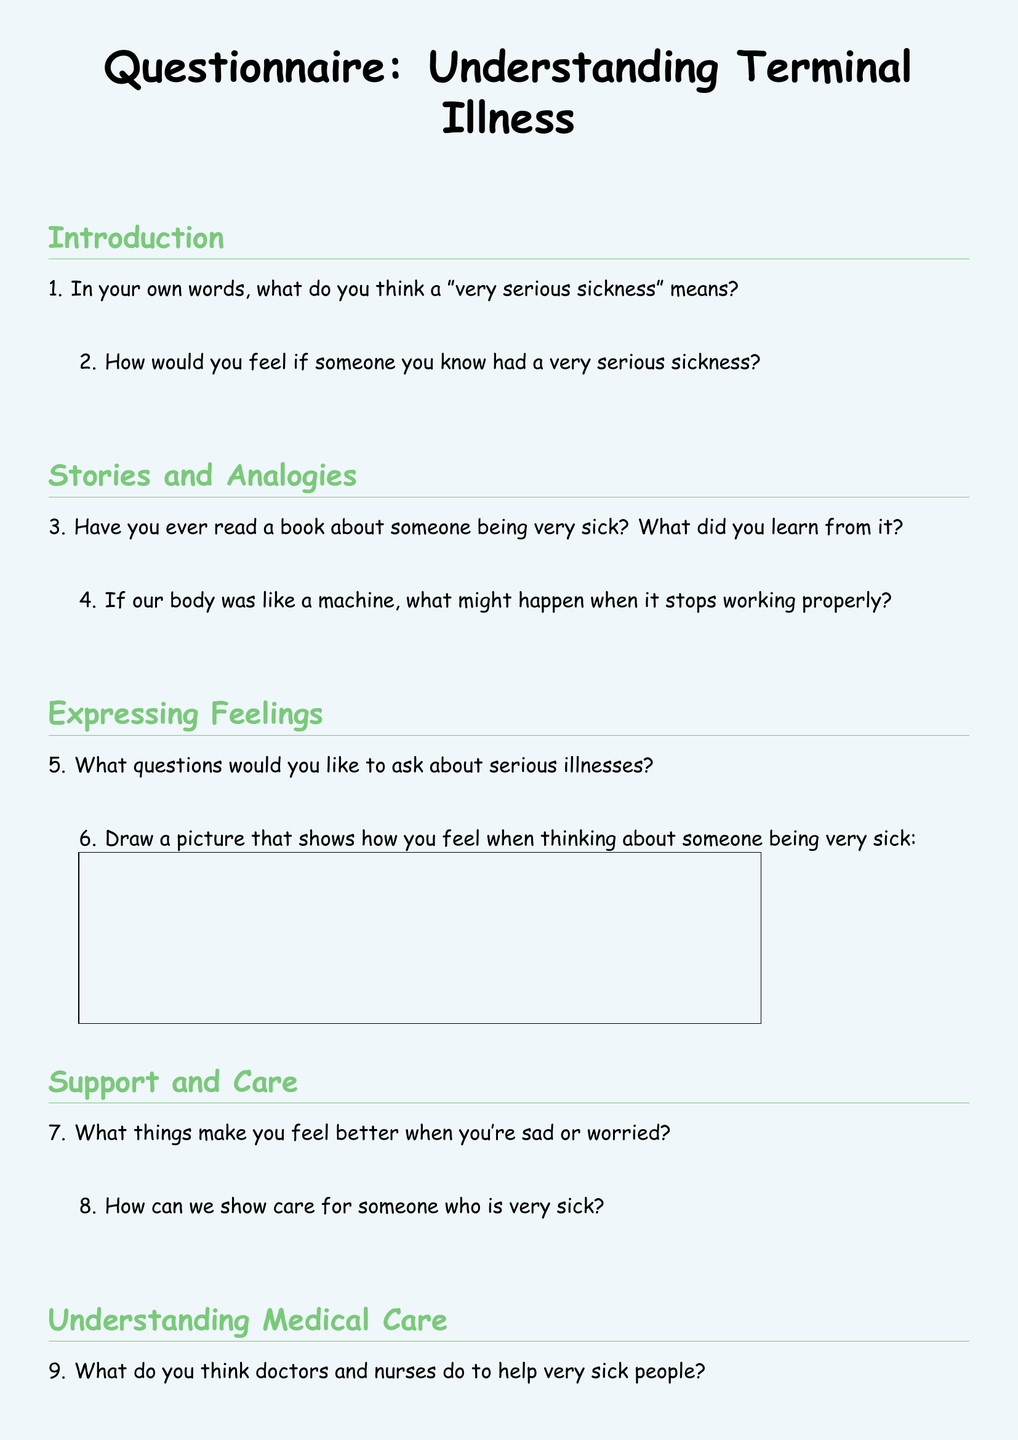What is the title of the document? The title is prominently displayed at the top of the document, introducing the main topic.
Answer: Questionnaire: Understanding Terminal Illness How many sections are in the questionnaire? The document contains various sections that pertain to different topics, each labeled distinctly.
Answer: 4 What color is the page background? The coloration of the page is apparent when looking at the document, providing a soft visual effect.
Answer: Pastel blue What is the first question in the Introduction section? The first question is listed directly under the Introduction section, focusing on understanding a concept.
Answer: In your own words, what do you think a "very serious sickness" means? What is one way to show care for someone who is very sick? This question prompts reflection on emotional support, asking for actions to take regarding someone ill.
Answer: Answer may vary (subjective) What might happen when a body stops working properly? This question invites interpretation of bodily functions through analogy, specifically regarding machines.
Answer: Answer may vary (subjective) 